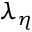Convert formula to latex. <formula><loc_0><loc_0><loc_500><loc_500>\lambda _ { \eta }</formula> 